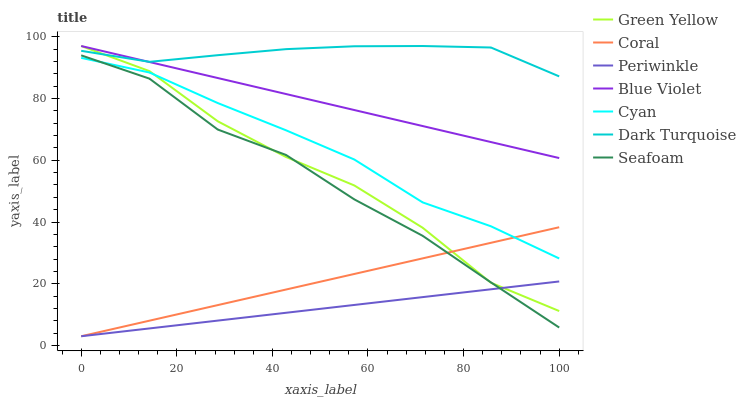Does Periwinkle have the minimum area under the curve?
Answer yes or no. Yes. Does Dark Turquoise have the maximum area under the curve?
Answer yes or no. Yes. Does Coral have the minimum area under the curve?
Answer yes or no. No. Does Coral have the maximum area under the curve?
Answer yes or no. No. Is Blue Violet the smoothest?
Answer yes or no. Yes. Is Green Yellow the roughest?
Answer yes or no. Yes. Is Coral the smoothest?
Answer yes or no. No. Is Coral the roughest?
Answer yes or no. No. Does Coral have the lowest value?
Answer yes or no. Yes. Does Seafoam have the lowest value?
Answer yes or no. No. Does Blue Violet have the highest value?
Answer yes or no. Yes. Does Coral have the highest value?
Answer yes or no. No. Is Periwinkle less than Dark Turquoise?
Answer yes or no. Yes. Is Blue Violet greater than Seafoam?
Answer yes or no. Yes. Does Coral intersect Green Yellow?
Answer yes or no. Yes. Is Coral less than Green Yellow?
Answer yes or no. No. Is Coral greater than Green Yellow?
Answer yes or no. No. Does Periwinkle intersect Dark Turquoise?
Answer yes or no. No. 